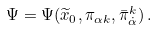<formula> <loc_0><loc_0><loc_500><loc_500>\Psi = \Psi ( \widetilde { x } _ { 0 } , \pi _ { \alpha k } , \bar { \pi } _ { \dot { \alpha } } ^ { k } ) \, .</formula> 